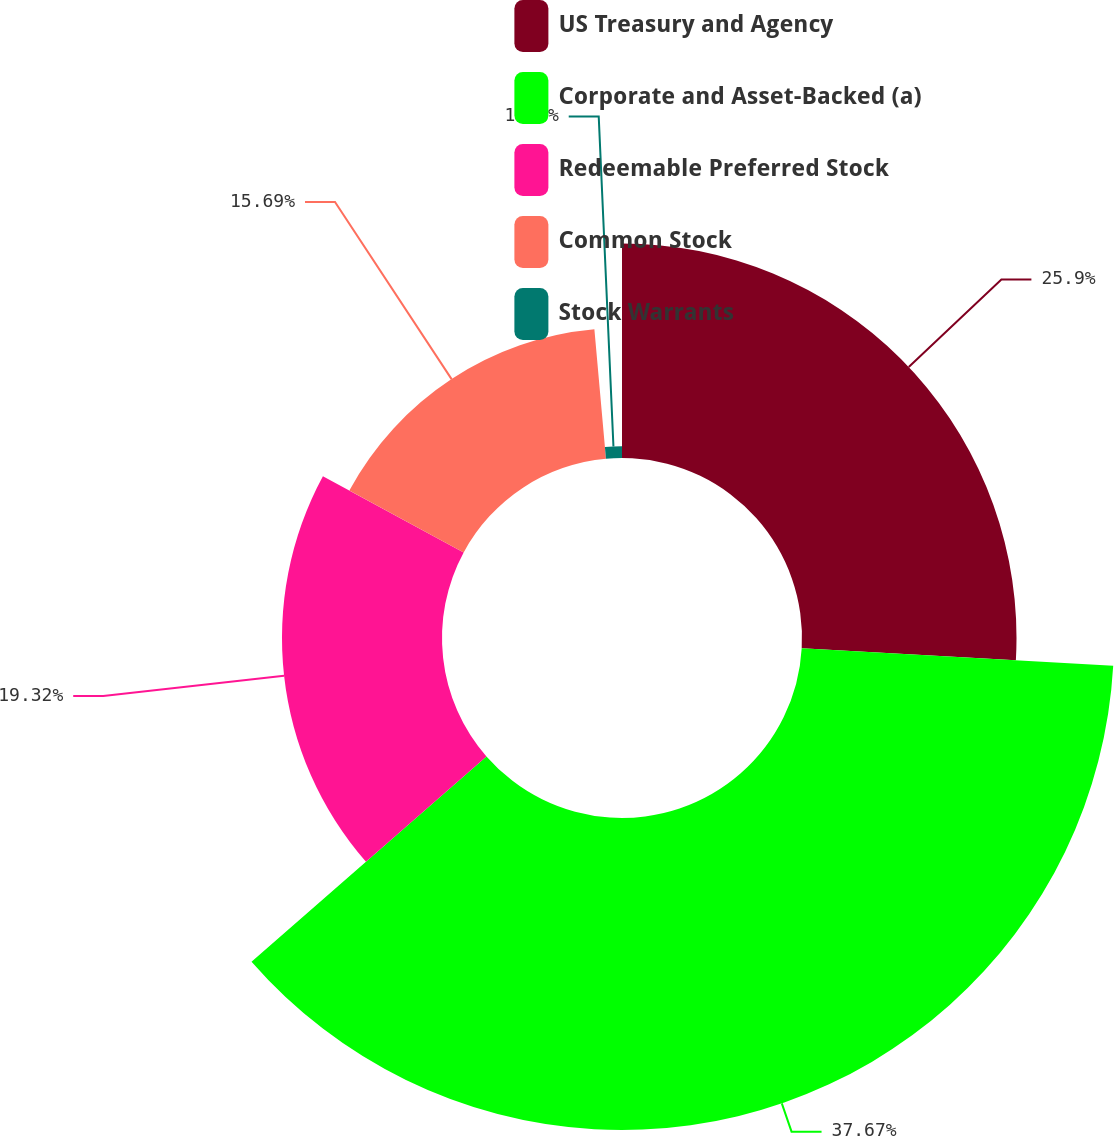Convert chart to OTSL. <chart><loc_0><loc_0><loc_500><loc_500><pie_chart><fcel>US Treasury and Agency<fcel>Corporate and Asset-Backed (a)<fcel>Redeemable Preferred Stock<fcel>Common Stock<fcel>Stock Warrants<nl><fcel>25.9%<fcel>37.67%<fcel>19.32%<fcel>15.69%<fcel>1.42%<nl></chart> 